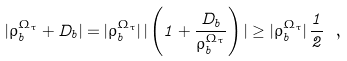Convert formula to latex. <formula><loc_0><loc_0><loc_500><loc_500>| \rho ^ { \Omega _ { \tau } } _ { b } + D _ { b } | = | \rho ^ { \Omega _ { \tau } } _ { b } | \, | \left ( 1 + \frac { D _ { b } } { \rho ^ { \Omega _ { \tau } } _ { b } } \right ) | \geq | \rho ^ { \Omega _ { \tau } } _ { b } | \, \frac { 1 } { 2 } \ ,</formula> 